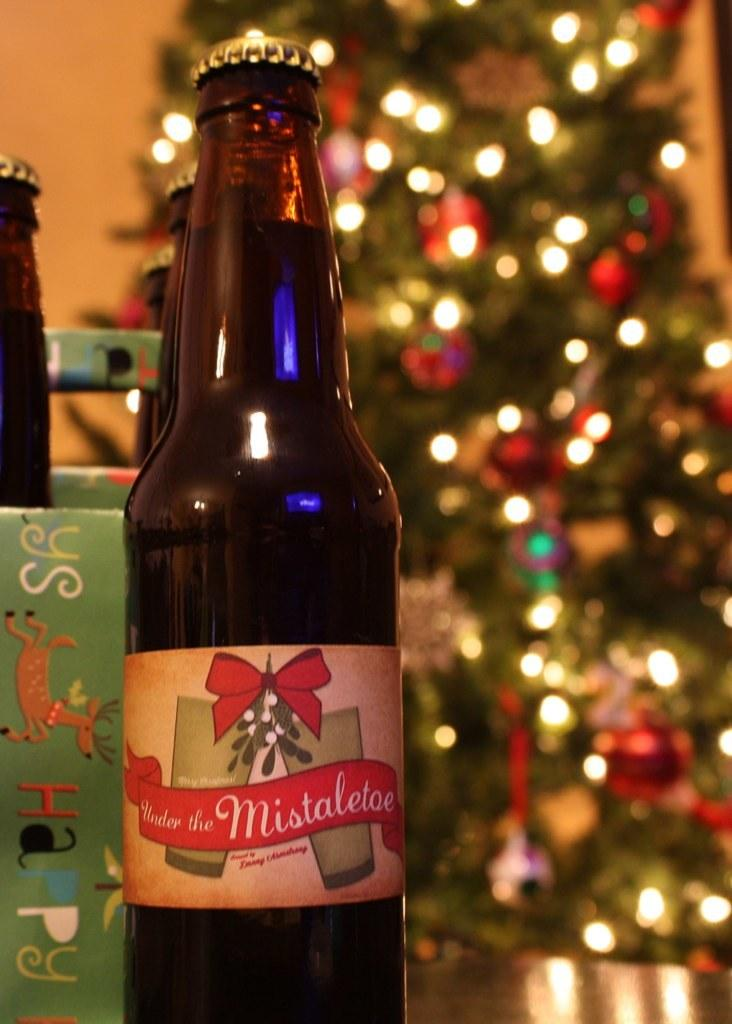What objects can be seen in the image? There are bottles in the image. What can be seen in the background of the image? There is a tree with full of lights in the background of the image. How many fairies can be seen in the image? There are no fairies present in the image. What is the level of disgust in the image? The image does not convey any emotions or feelings, such as disgust, so it cannot be determined from the image. 